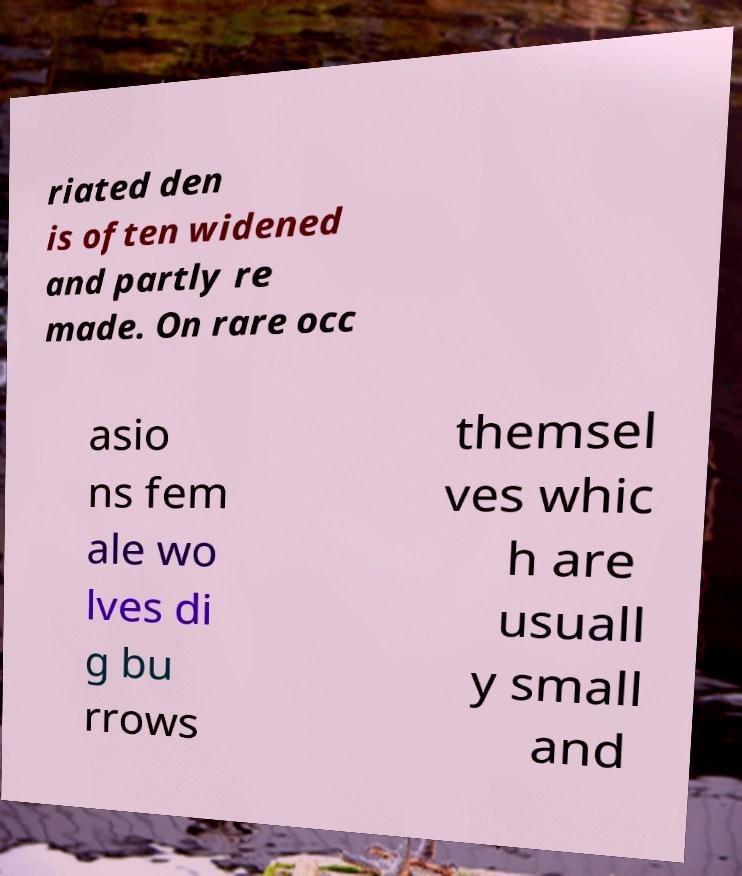Please read and relay the text visible in this image. What does it say? riated den is often widened and partly re made. On rare occ asio ns fem ale wo lves di g bu rrows themsel ves whic h are usuall y small and 